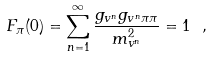<formula> <loc_0><loc_0><loc_500><loc_500>F _ { \pi } ( 0 ) = \sum _ { n = 1 } ^ { \infty } \frac { g _ { v ^ { n } } g _ { v ^ { n } \pi \pi } } { m _ { v ^ { n } } ^ { 2 } } = 1 \ ,</formula> 